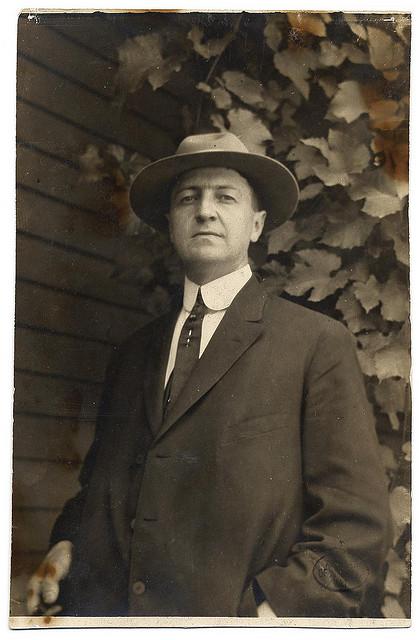What is he wearing?
Short answer required. Suit. Is that a straw hat?
Be succinct. No. Was this picture made on a sunny day?
Short answer required. Yes. Was this taken in the 60's?
Keep it brief. No. What color tie does the man have?
Quick response, please. Black. What color is the man's jacket?
Quick response, please. Black. What is on his head?
Be succinct. Hat. What kind of suit is that?
Concise answer only. Business. 